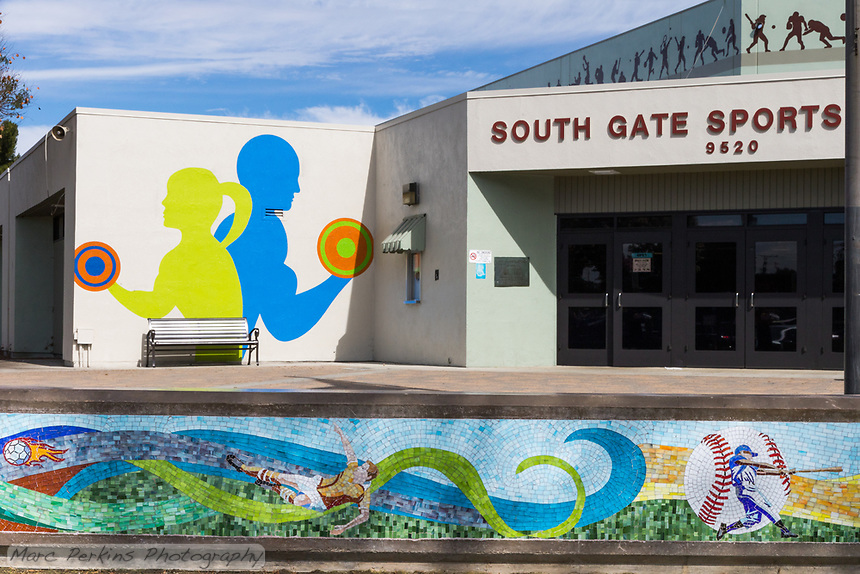Considering the sports themes represented in the murals and the frieze above the entrance, what types of community events or activities might be hosted inside this facility, and how do these artistic elements reflect the facility's purpose? The vibrant murals and frieze at the South Gate Sports facility vividly suggest that it could be a hub for diverse sports-related activities, ranging from swimming and weightlifting to baseball and soccer. These illustrations not only advertise the types of activities available but also culturally enrich the facility, making it an appealing and inspirational space for locals. Engaging the community through these artistic representations fosters local pride and encourages active participation in these various sports. This artistic approach would likely make the facility a central point in promoting health, wellness, and community spirit among its visitors. 